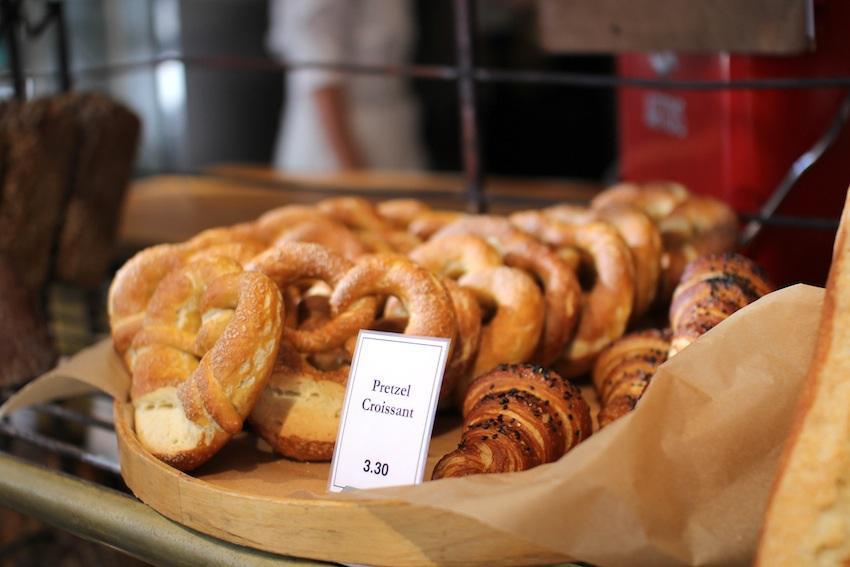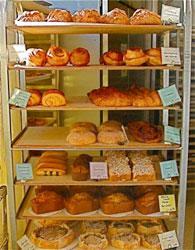The first image is the image on the left, the second image is the image on the right. For the images displayed, is the sentence "In at least one image there is a single brown front door under blue signage." factually correct? Answer yes or no. No. The first image is the image on the left, the second image is the image on the right. For the images shown, is this caption "There is a metal rack with various breads and pastries on it, there are tags in the image on the shelves labeling the products" true? Answer yes or no. Yes. 